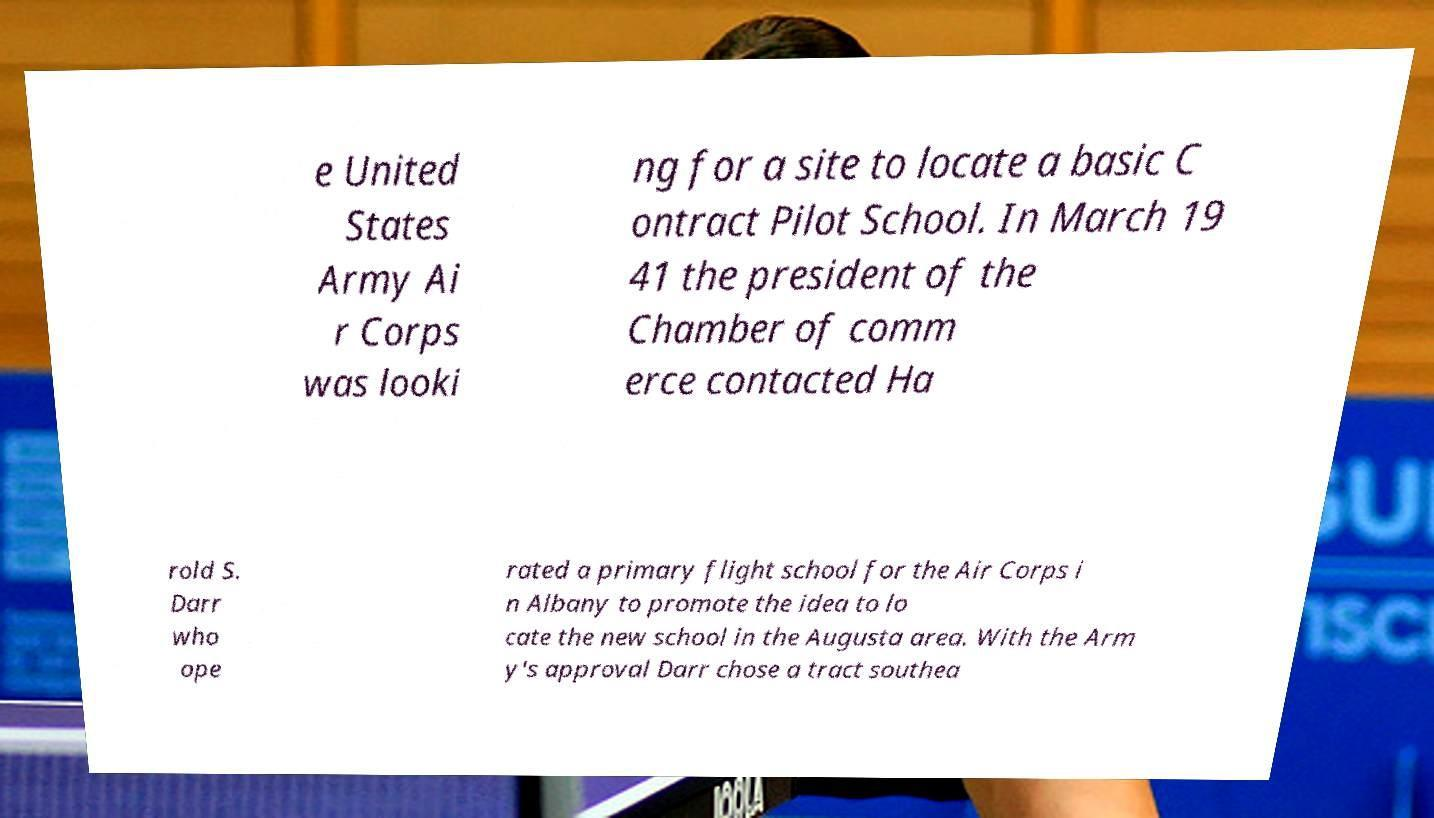What messages or text are displayed in this image? I need them in a readable, typed format. e United States Army Ai r Corps was looki ng for a site to locate a basic C ontract Pilot School. In March 19 41 the president of the Chamber of comm erce contacted Ha rold S. Darr who ope rated a primary flight school for the Air Corps i n Albany to promote the idea to lo cate the new school in the Augusta area. With the Arm y's approval Darr chose a tract southea 